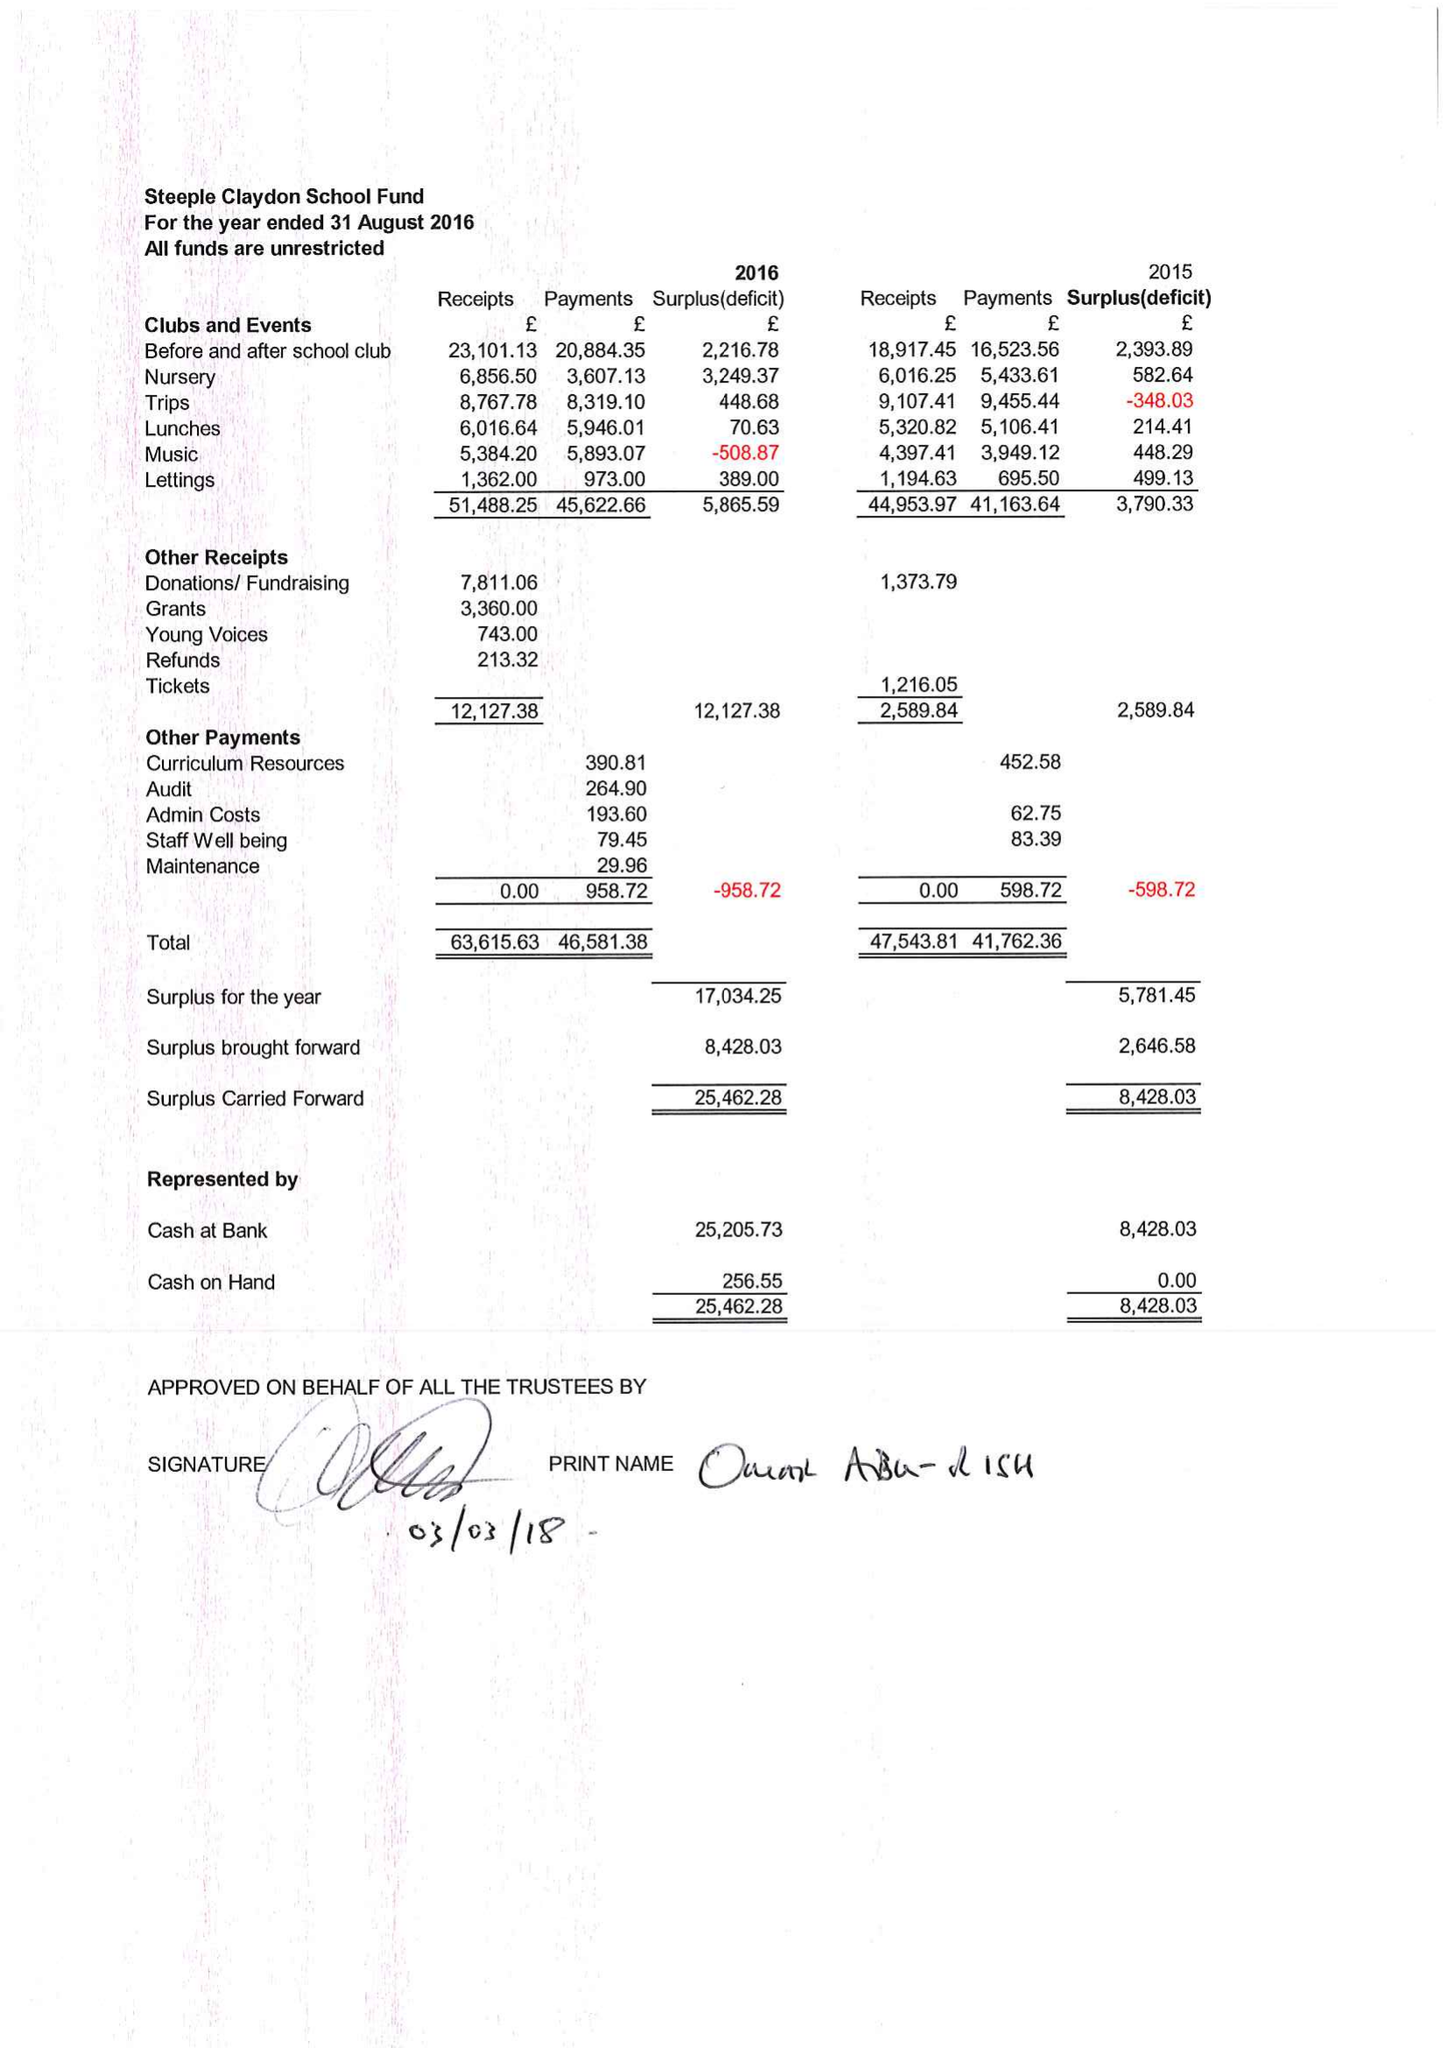What is the value for the report_date?
Answer the question using a single word or phrase. 2016-08-31 